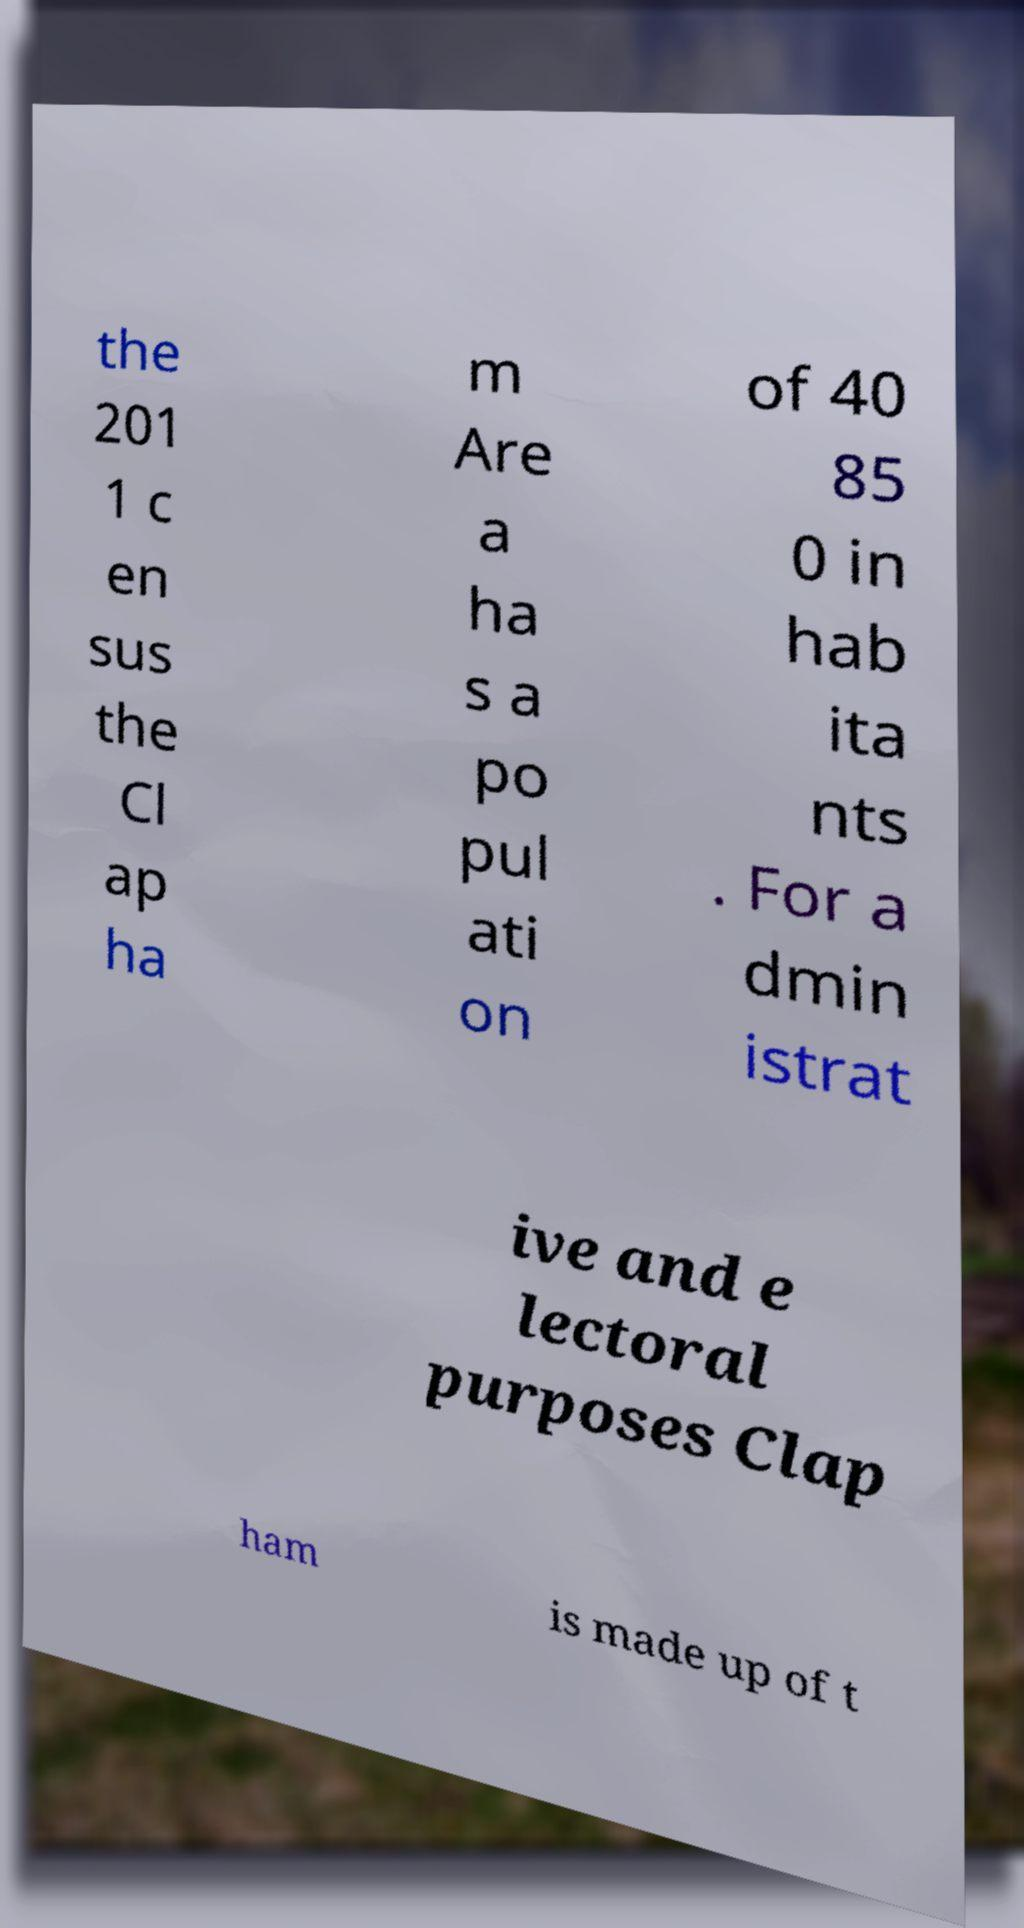Can you read and provide the text displayed in the image?This photo seems to have some interesting text. Can you extract and type it out for me? the 201 1 c en sus the Cl ap ha m Are a ha s a po pul ati on of 40 85 0 in hab ita nts . For a dmin istrat ive and e lectoral purposes Clap ham is made up of t 